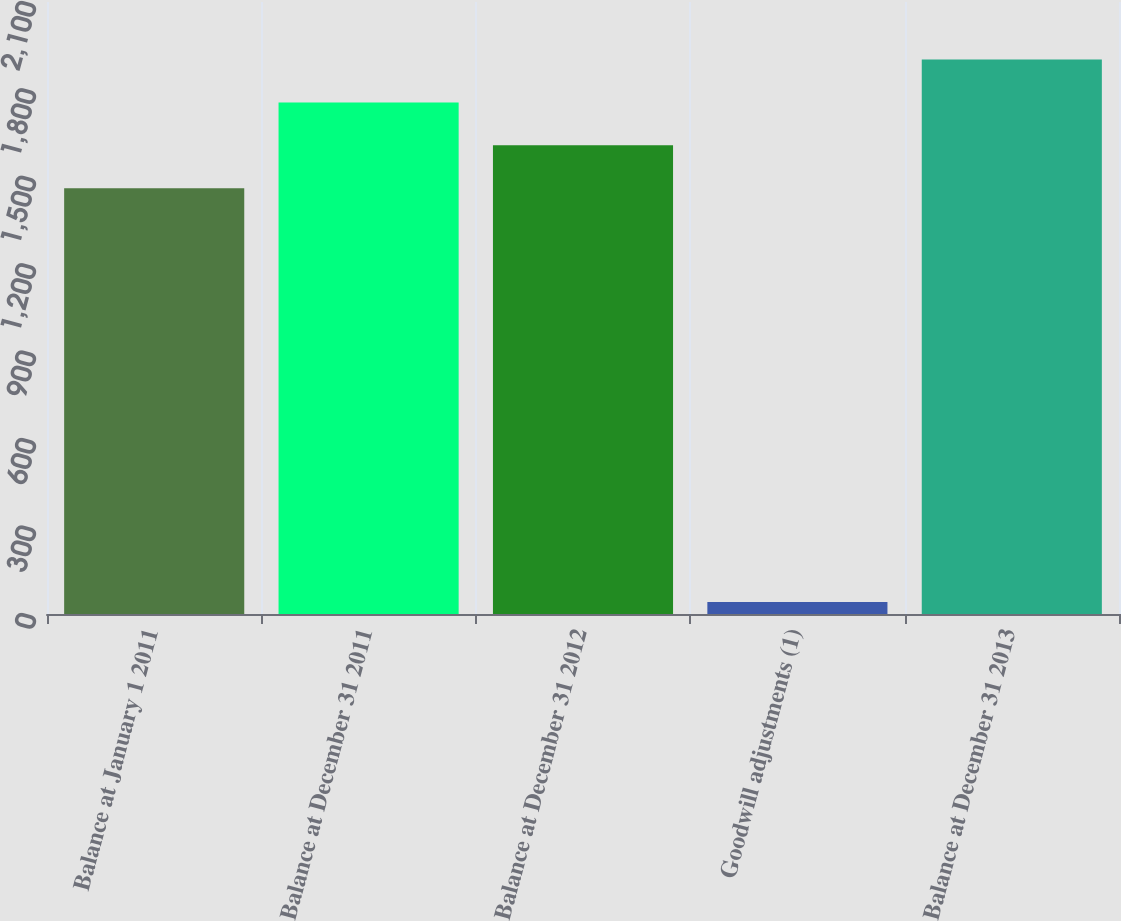<chart> <loc_0><loc_0><loc_500><loc_500><bar_chart><fcel>Balance at January 1 2011<fcel>Balance at December 31 2011<fcel>Balance at December 31 2012<fcel>Goodwill adjustments (1)<fcel>Balance at December 31 2013<nl><fcel>1461<fcel>1755.4<fcel>1608.2<fcel>41<fcel>1902.6<nl></chart> 